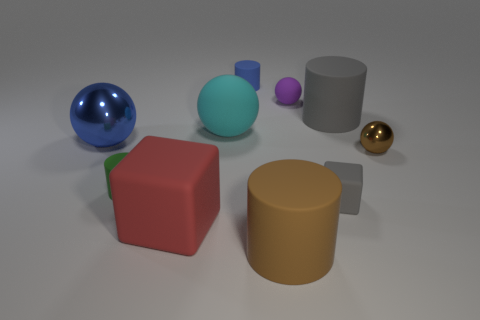There is a rubber cylinder that is the same color as the tiny shiny thing; what size is it?
Provide a succinct answer. Large. Are there any large rubber blocks of the same color as the tiny matte cube?
Offer a terse response. No. There is a ball that is the same size as the blue metal object; what color is it?
Ensure brevity in your answer.  Cyan. How many gray matte cubes are behind the metallic sphere that is to the left of the blue cylinder?
Make the answer very short. 0. What number of objects are either tiny cylinders that are behind the tiny metal thing or gray shiny balls?
Provide a succinct answer. 1. How many green cylinders are the same material as the tiny blue cylinder?
Give a very brief answer. 1. What shape is the big matte thing that is the same color as the small metallic sphere?
Provide a short and direct response. Cylinder. Are there an equal number of spheres that are behind the gray rubber cube and large matte objects?
Keep it short and to the point. Yes. There is a cube in front of the small matte cube; how big is it?
Provide a succinct answer. Large. What number of big objects are either red balls or blue matte objects?
Make the answer very short. 0. 